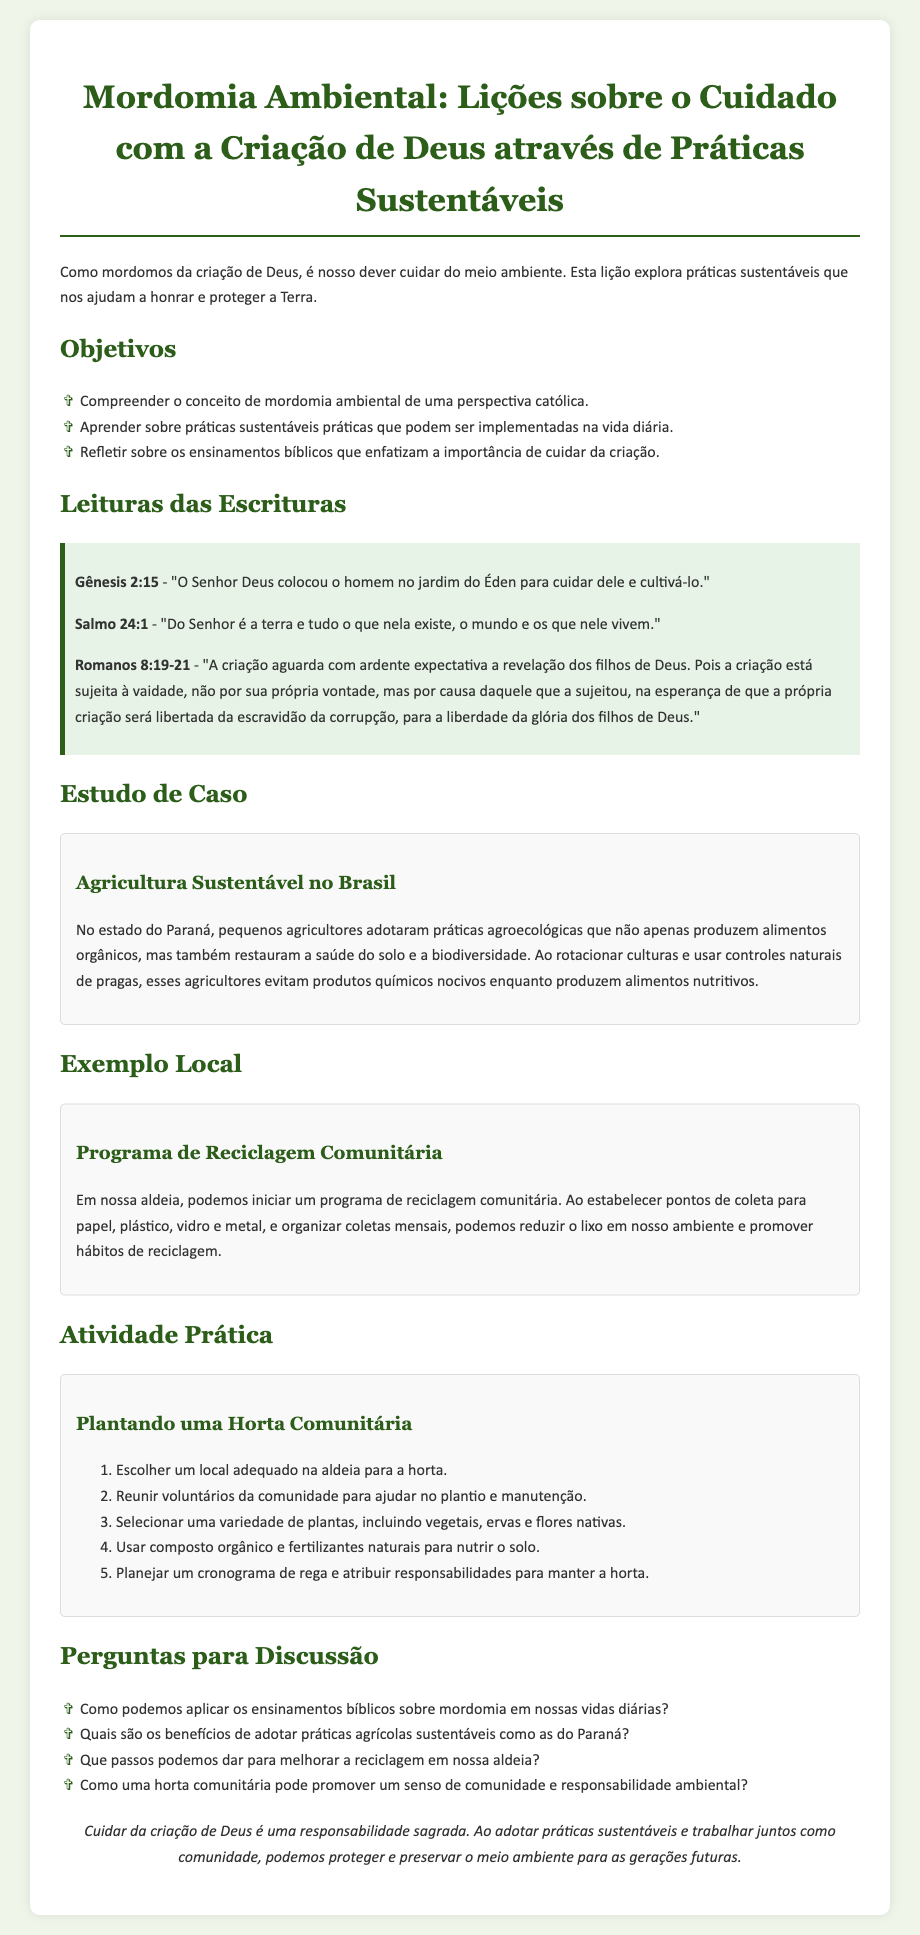Qual é o título da lição? O título da lição é a principal identificação do documento, que é "Mordomia Ambiental: Lições sobre o Cuidado com a Criação de Deus através de Práticas Sustentáveis".
Answer: Mordomia Ambiental: Lições sobre o Cuidado com a Criação de Deus através de Práticas Sustentáveis Quantos objetivos estão listados? O número de objetivos é indicado na seção "Objetivos", onde são mencionados três objetivos principais.
Answer: 3 Qual é um dos versículos das Escrituras citados? A lição inclui várias leituras das Escrituras, um exemplo é Gênesis 2:15.
Answer: Gênesis 2:15 O que é sugerido como uma prática local? O documento sugere iniciar um programa específico que visa melhorar a sustentabilidade na comunidade.
Answer: Programa de Reciclagem Comunitária Quantas etapas são sugeridas para a atividade prática? O número de etapas na atividade prática sobre plantar uma horta comunitária é indicado na seção correspondente.
Answer: 5 Como uma horta comunitária pode beneficiar a comunidade? A atividade envolve reflexão sobre os resultados e benefícios de um projeto comunitário, que é discutido nas perguntas.
Answer: Promover um senso de comunidade Qual é uma das leis espirituais mencionadas sobre a criação? As Escrituras são usadas para enfatizar a importância do cuidado, um exemplo é Romanos 8:19-21.
Answer: Romanos 8:19-21 Quais os temas abordados nas perguntas para discussão? As perguntas abordam temas relevantes sobre práticas sustentáveis e aplicação de ensinamentos bíblicos.
Answer: Mordomia, práticas agrícolas, reciclagem, comunidade 